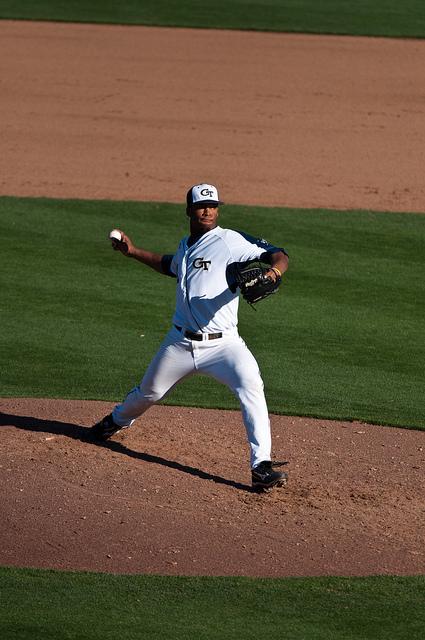How many field positions are visible in this picture?
Quick response, please. 1. What sport is this?
Quick response, please. Baseball. What hand does the pitcher throw with?
Quick response, please. Right. 